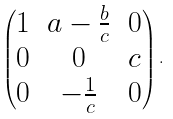<formula> <loc_0><loc_0><loc_500><loc_500>\begin{pmatrix} 1 & a - \frac { b } { c } & 0 \\ 0 & 0 & c \\ 0 & - \frac { 1 } { c } & 0 \end{pmatrix} .</formula> 